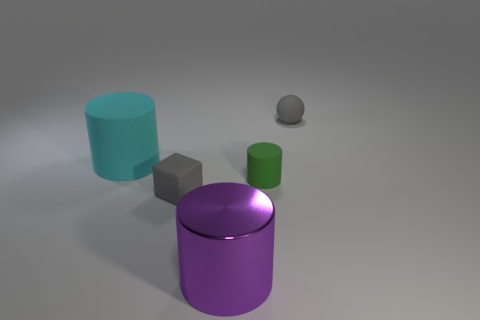Are there any other things that have the same color as the shiny cylinder?
Provide a succinct answer. No. What shape is the big cyan object that is made of the same material as the tiny cylinder?
Your answer should be very brief. Cylinder. What is the small thing that is both on the left side of the ball and behind the tiny cube made of?
Make the answer very short. Rubber. Does the small block have the same color as the rubber sphere?
Your answer should be very brief. Yes. What shape is the small matte object that is the same color as the rubber block?
Your response must be concise. Sphere. How many green things are the same shape as the purple object?
Your answer should be compact. 1. There is a block that is the same material as the small green thing; what is its size?
Your answer should be compact. Small. Is the size of the gray sphere the same as the gray rubber cube?
Your answer should be compact. Yes. Are any large cyan matte cylinders visible?
Give a very brief answer. Yes. There is a ball that is the same color as the rubber cube; what is its size?
Provide a short and direct response. Small. 